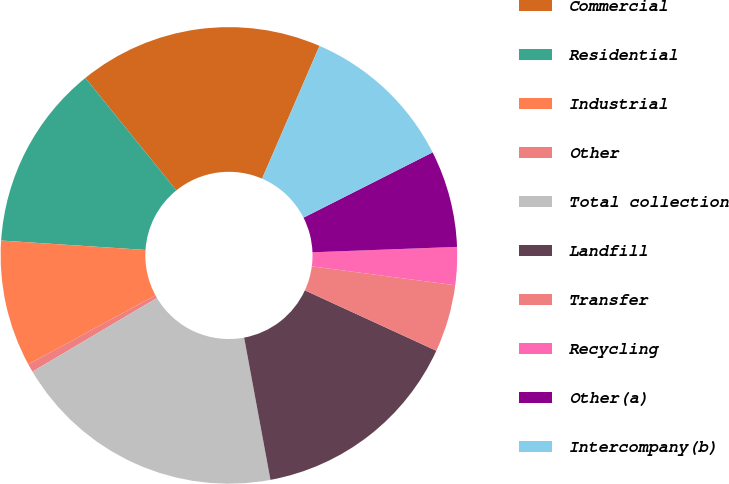Convert chart to OTSL. <chart><loc_0><loc_0><loc_500><loc_500><pie_chart><fcel>Commercial<fcel>Residential<fcel>Industrial<fcel>Other<fcel>Total collection<fcel>Landfill<fcel>Transfer<fcel>Recycling<fcel>Other(a)<fcel>Intercompany(b)<nl><fcel>17.32%<fcel>13.14%<fcel>8.95%<fcel>0.59%<fcel>19.41%<fcel>15.23%<fcel>4.77%<fcel>2.68%<fcel>6.86%<fcel>11.05%<nl></chart> 